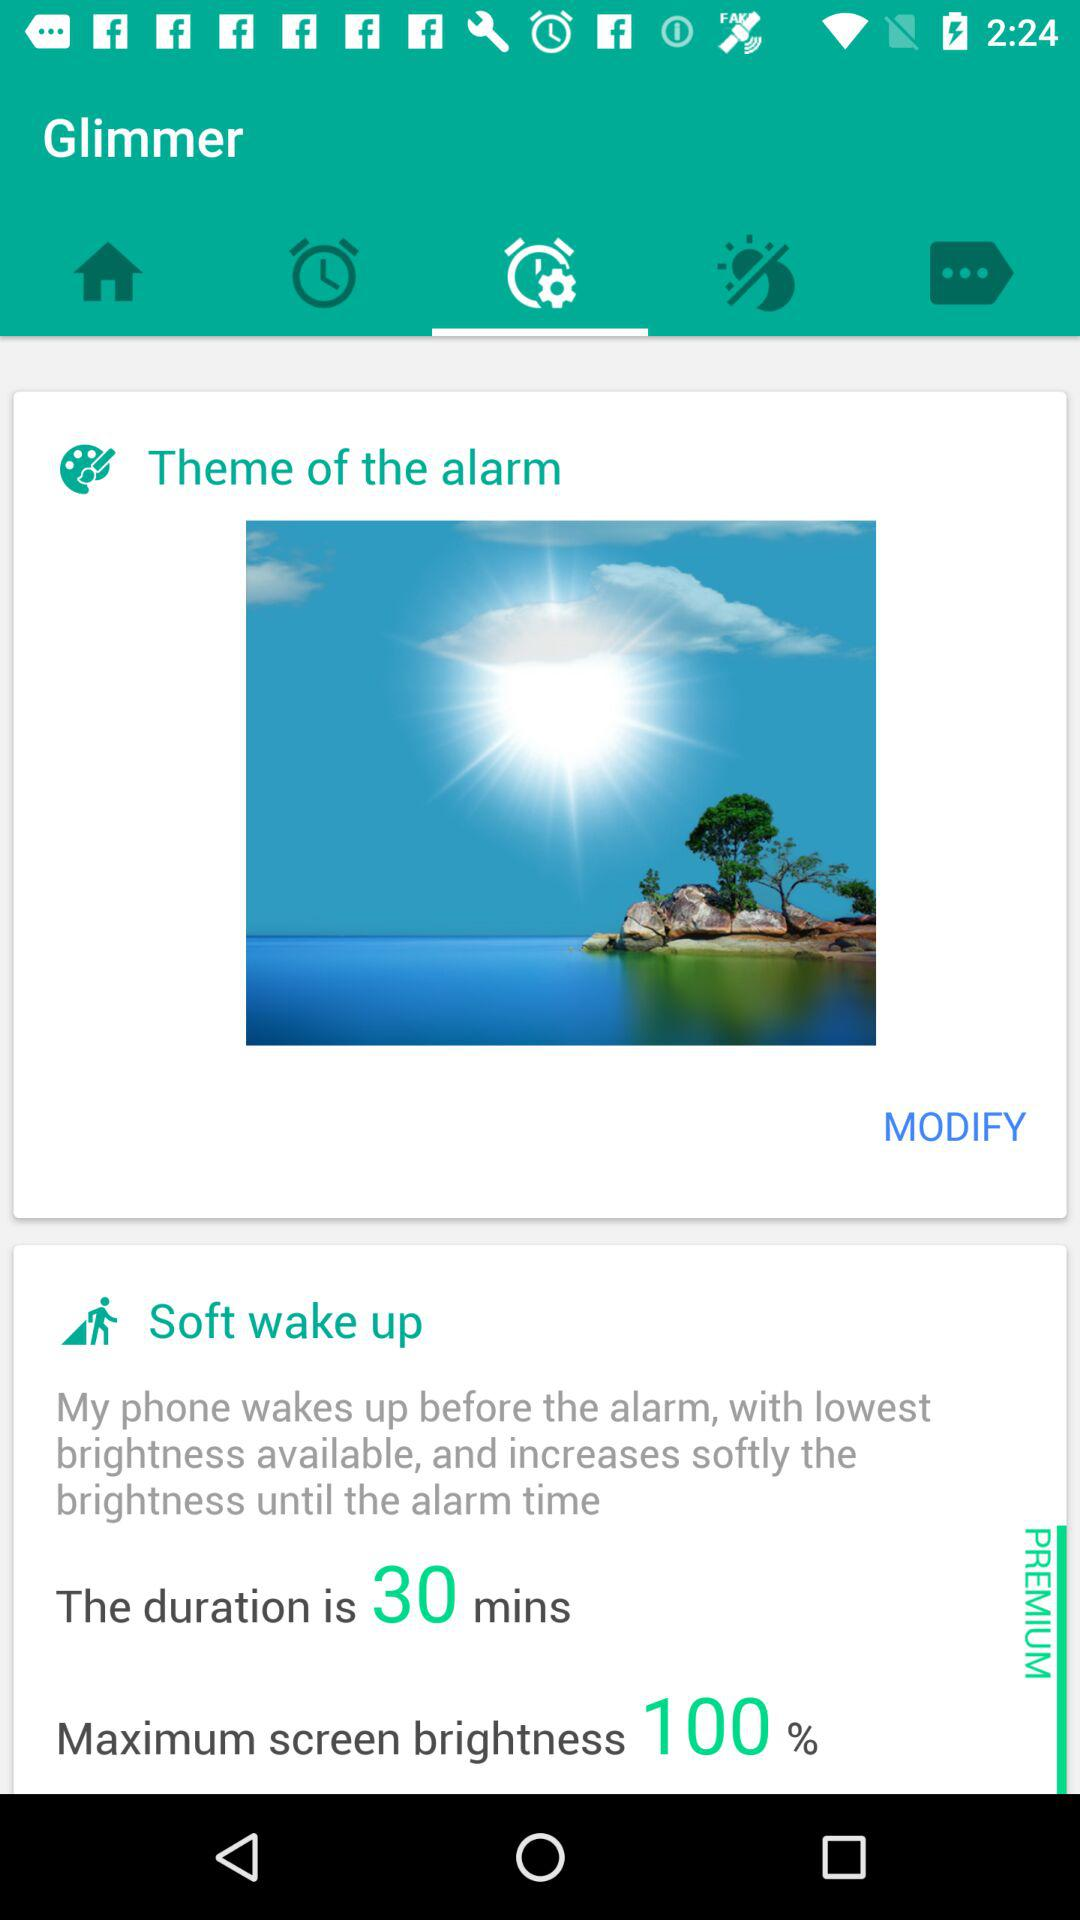What is the theme of the alarm?
When the provided information is insufficient, respond with <no answer>. <no answer> 